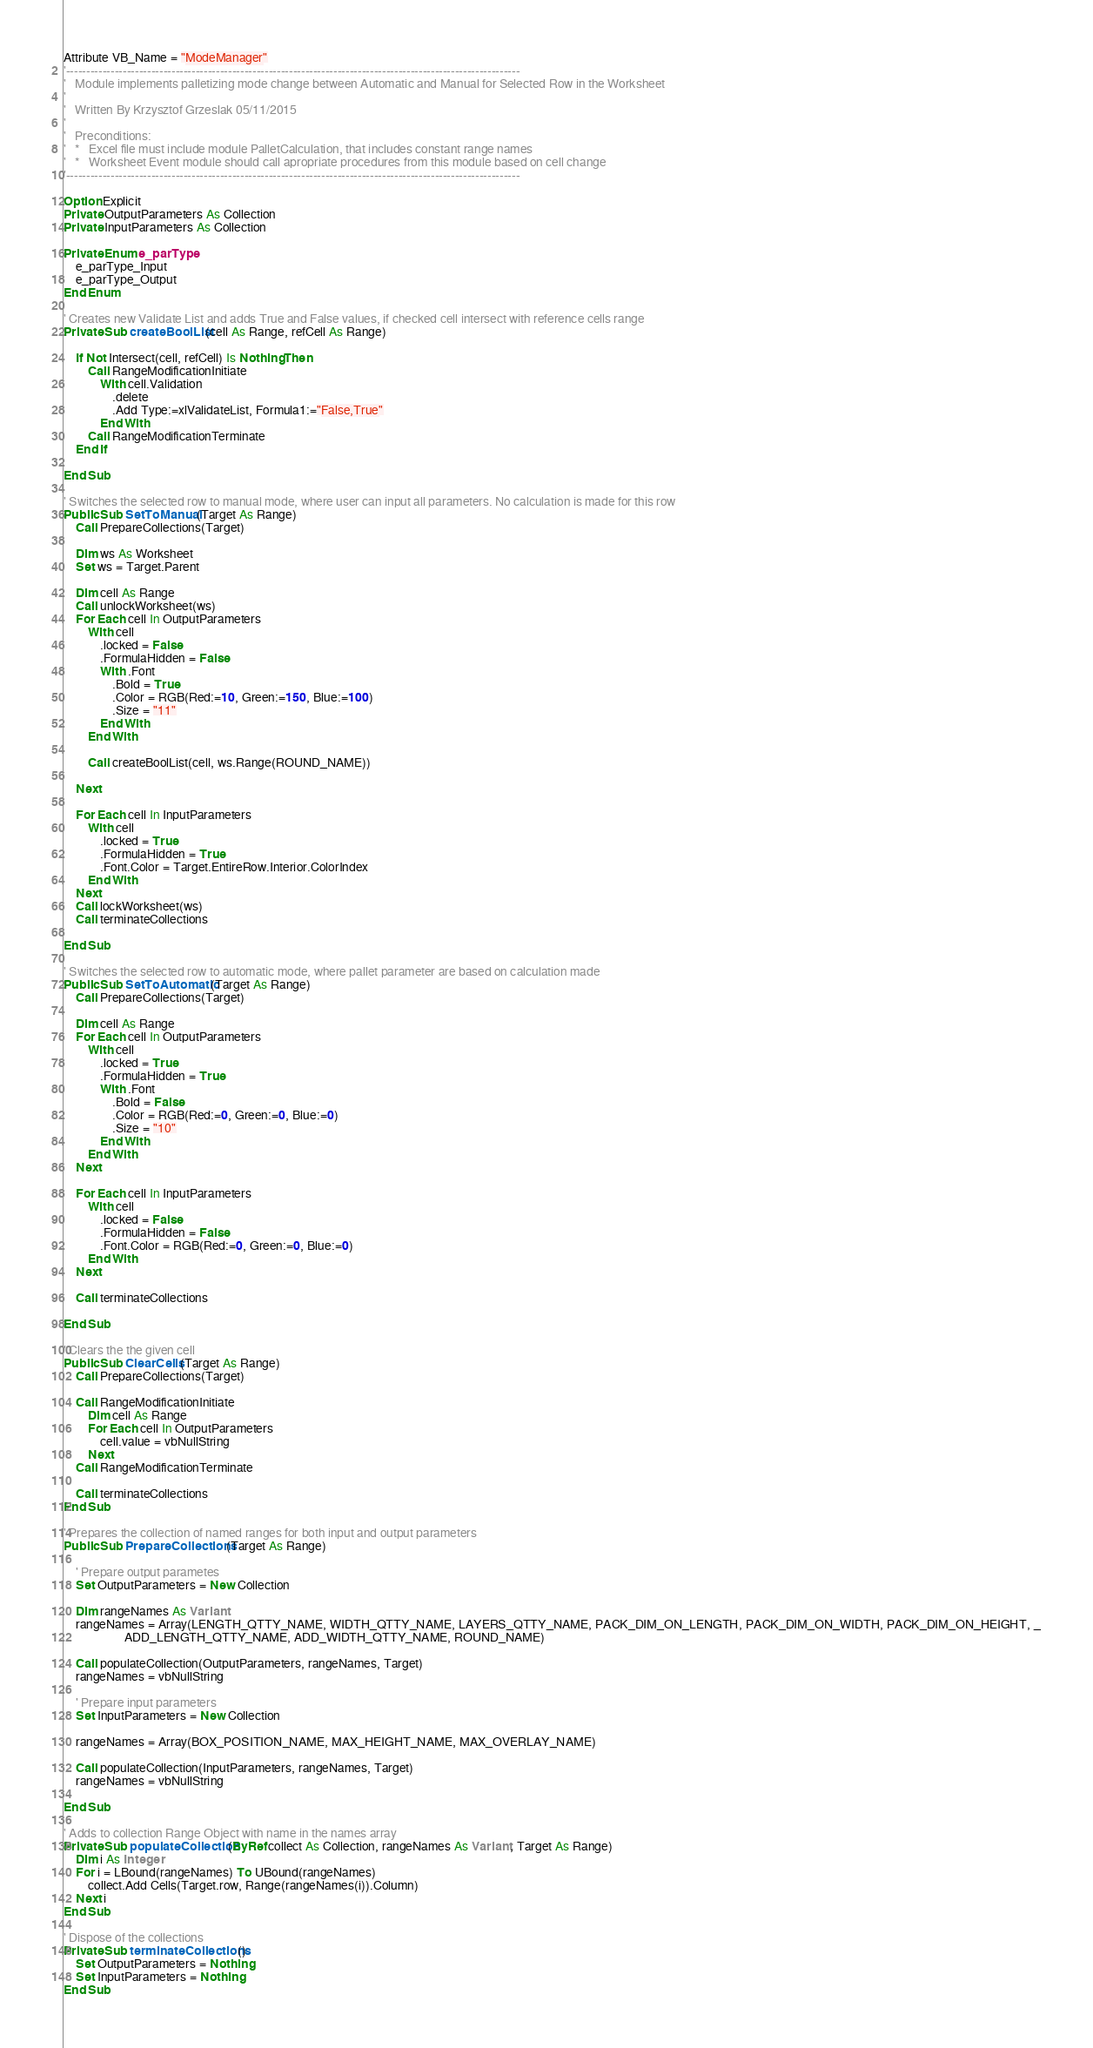Convert code to text. <code><loc_0><loc_0><loc_500><loc_500><_VisualBasic_>Attribute VB_Name = "ModeManager"
'----------------------------------------------------------------------------------------------------------------
'   Module implements palletizing mode change between Automatic and Manual for Selected Row in the Worksheet
'
'   Written By Krzysztof Grzeslak 05/11/2015
'
'   Preconditions:
'   *   Excel file must include module PalletCalculation, that includes constant range names
'   *   Worksheet Event module should call apropriate procedures from this module based on cell change
'----------------------------------------------------------------------------------------------------------------

Option Explicit
Private OutputParameters As Collection
Private InputParameters As Collection

Private Enum e_parType
    e_parType_Input
    e_parType_Output
End Enum

' Creates new Validate List and adds True and False values, if checked cell intersect with reference cells range
Private Sub createBoolList(cell As Range, refCell As Range)
    
    If Not Intersect(cell, refCell) Is Nothing Then
        Call RangeModificationInitiate
            With cell.Validation
                .delete
                .Add Type:=xlValidateList, Formula1:="False,True"
            End With
        Call RangeModificationTerminate
    End If
    
End Sub

' Switches the selected row to manual mode, where user can input all parameters. No calculation is made for this row
Public Sub SetToManual(Target As Range)
    Call PrepareCollections(Target)
    
    Dim ws As Worksheet
    Set ws = Target.Parent
    
    Dim cell As Range
    Call unlockWorksheet(ws)
    For Each cell In OutputParameters
        With cell
            .locked = False
            .FormulaHidden = False
            With .Font
                .Bold = True
                .Color = RGB(Red:=10, Green:=150, Blue:=100)
                .Size = "11"
            End With
        End With
        
        Call createBoolList(cell, ws.Range(ROUND_NAME))

    Next
    
    For Each cell In InputParameters
        With cell
            .locked = True
            .FormulaHidden = True
            .Font.Color = Target.EntireRow.Interior.ColorIndex
        End With
    Next
    Call lockWorksheet(ws)
    Call terminateCollections
    
End Sub

' Switches the selected row to automatic mode, where pallet parameter are based on calculation made
Public Sub SetToAutomatic(Target As Range)
    Call PrepareCollections(Target)
    
    Dim cell As Range
    For Each cell In OutputParameters
        With cell
            .locked = True
            .FormulaHidden = True
            With .Font
                .Bold = False
                .Color = RGB(Red:=0, Green:=0, Blue:=0)
                .Size = "10"
            End With
        End With
    Next
    
    For Each cell In InputParameters
        With cell
            .locked = False
            .FormulaHidden = False
            .Font.Color = RGB(Red:=0, Green:=0, Blue:=0)
        End With
    Next
    
    Call terminateCollections

End Sub

' Clears the the given cell
Public Sub ClearCells(Target As Range)
    Call PrepareCollections(Target)
    
    Call RangeModificationInitiate
        Dim cell As Range
        For Each cell In OutputParameters
            cell.value = vbNullString
        Next
    Call RangeModificationTerminate
    
    Call terminateCollections
End Sub

' Prepares the collection of named ranges for both input and output parameters
Public Sub PrepareCollections(Target As Range)
    
    ' Prepare output parametes
    Set OutputParameters = New Collection
    
    Dim rangeNames As Variant
    rangeNames = Array(LENGTH_QTTY_NAME, WIDTH_QTTY_NAME, LAYERS_QTTY_NAME, PACK_DIM_ON_LENGTH, PACK_DIM_ON_WIDTH, PACK_DIM_ON_HEIGHT, _
                    ADD_LENGTH_QTTY_NAME, ADD_WIDTH_QTTY_NAME, ROUND_NAME)
    
    Call populateCollection(OutputParameters, rangeNames, Target)
    rangeNames = vbNullString
    
    ' Prepare input parameters
    Set InputParameters = New Collection
    
    rangeNames = Array(BOX_POSITION_NAME, MAX_HEIGHT_NAME, MAX_OVERLAY_NAME)
    
    Call populateCollection(InputParameters, rangeNames, Target)
    rangeNames = vbNullString

End Sub

' Adds to collection Range Object with name in the names array
Private Sub populateCollection(ByRef collect As Collection, rangeNames As Variant, Target As Range)
    Dim i As Integer
    For i = LBound(rangeNames) To UBound(rangeNames)
        collect.Add Cells(Target.row, Range(rangeNames(i)).Column)
    Next i
End Sub

' Dispose of the collections
Private Sub terminateCollections()
    Set OutputParameters = Nothing
    Set InputParameters = Nothing
End Sub
</code> 